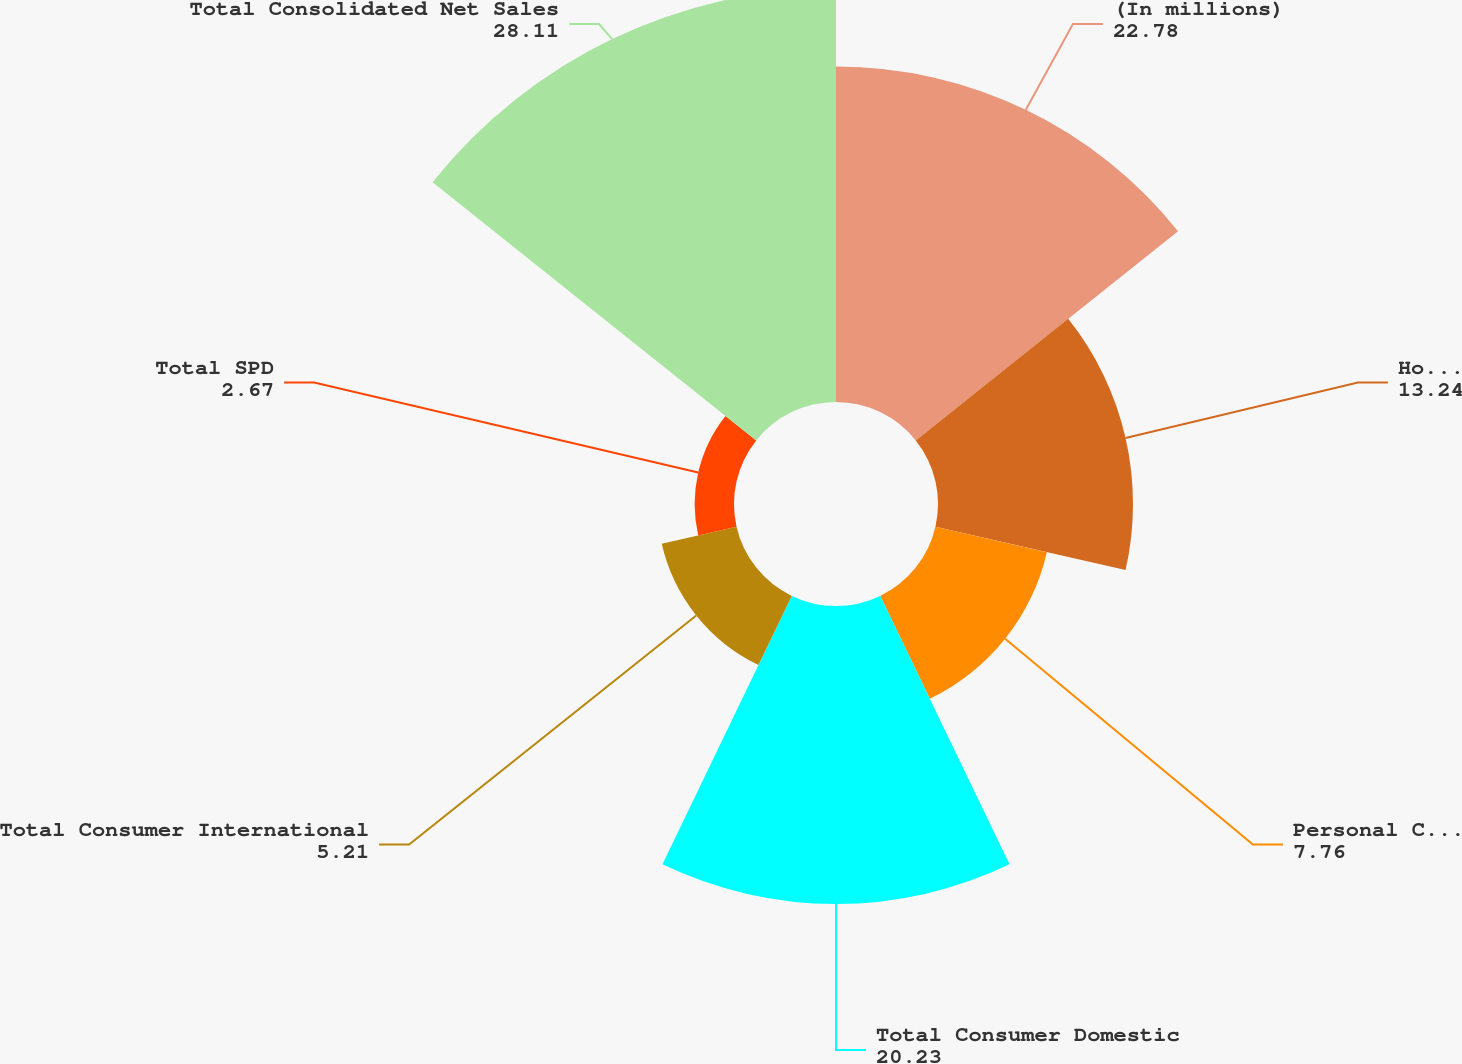Convert chart to OTSL. <chart><loc_0><loc_0><loc_500><loc_500><pie_chart><fcel>(In millions)<fcel>Household Products<fcel>Personal Care Products<fcel>Total Consumer Domestic<fcel>Total Consumer International<fcel>Total SPD<fcel>Total Consolidated Net Sales<nl><fcel>22.78%<fcel>13.24%<fcel>7.76%<fcel>20.23%<fcel>5.21%<fcel>2.67%<fcel>28.11%<nl></chart> 